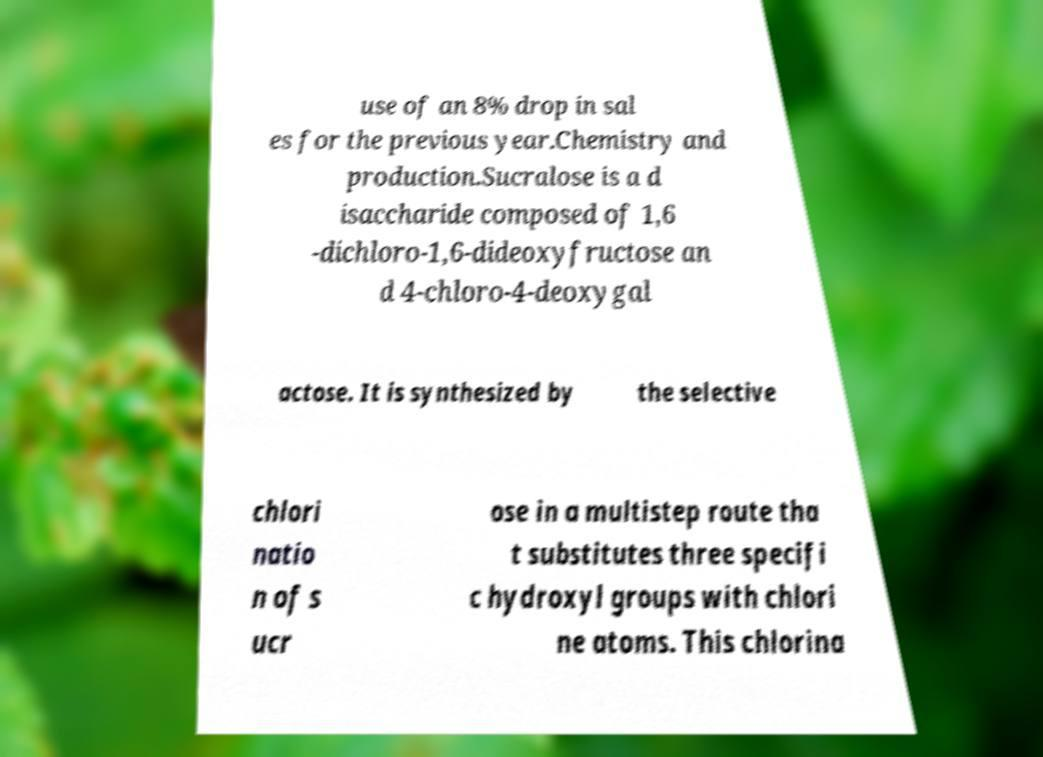Please read and relay the text visible in this image. What does it say? use of an 8% drop in sal es for the previous year.Chemistry and production.Sucralose is a d isaccharide composed of 1,6 -dichloro-1,6-dideoxyfructose an d 4-chloro-4-deoxygal actose. It is synthesized by the selective chlori natio n of s ucr ose in a multistep route tha t substitutes three specifi c hydroxyl groups with chlori ne atoms. This chlorina 